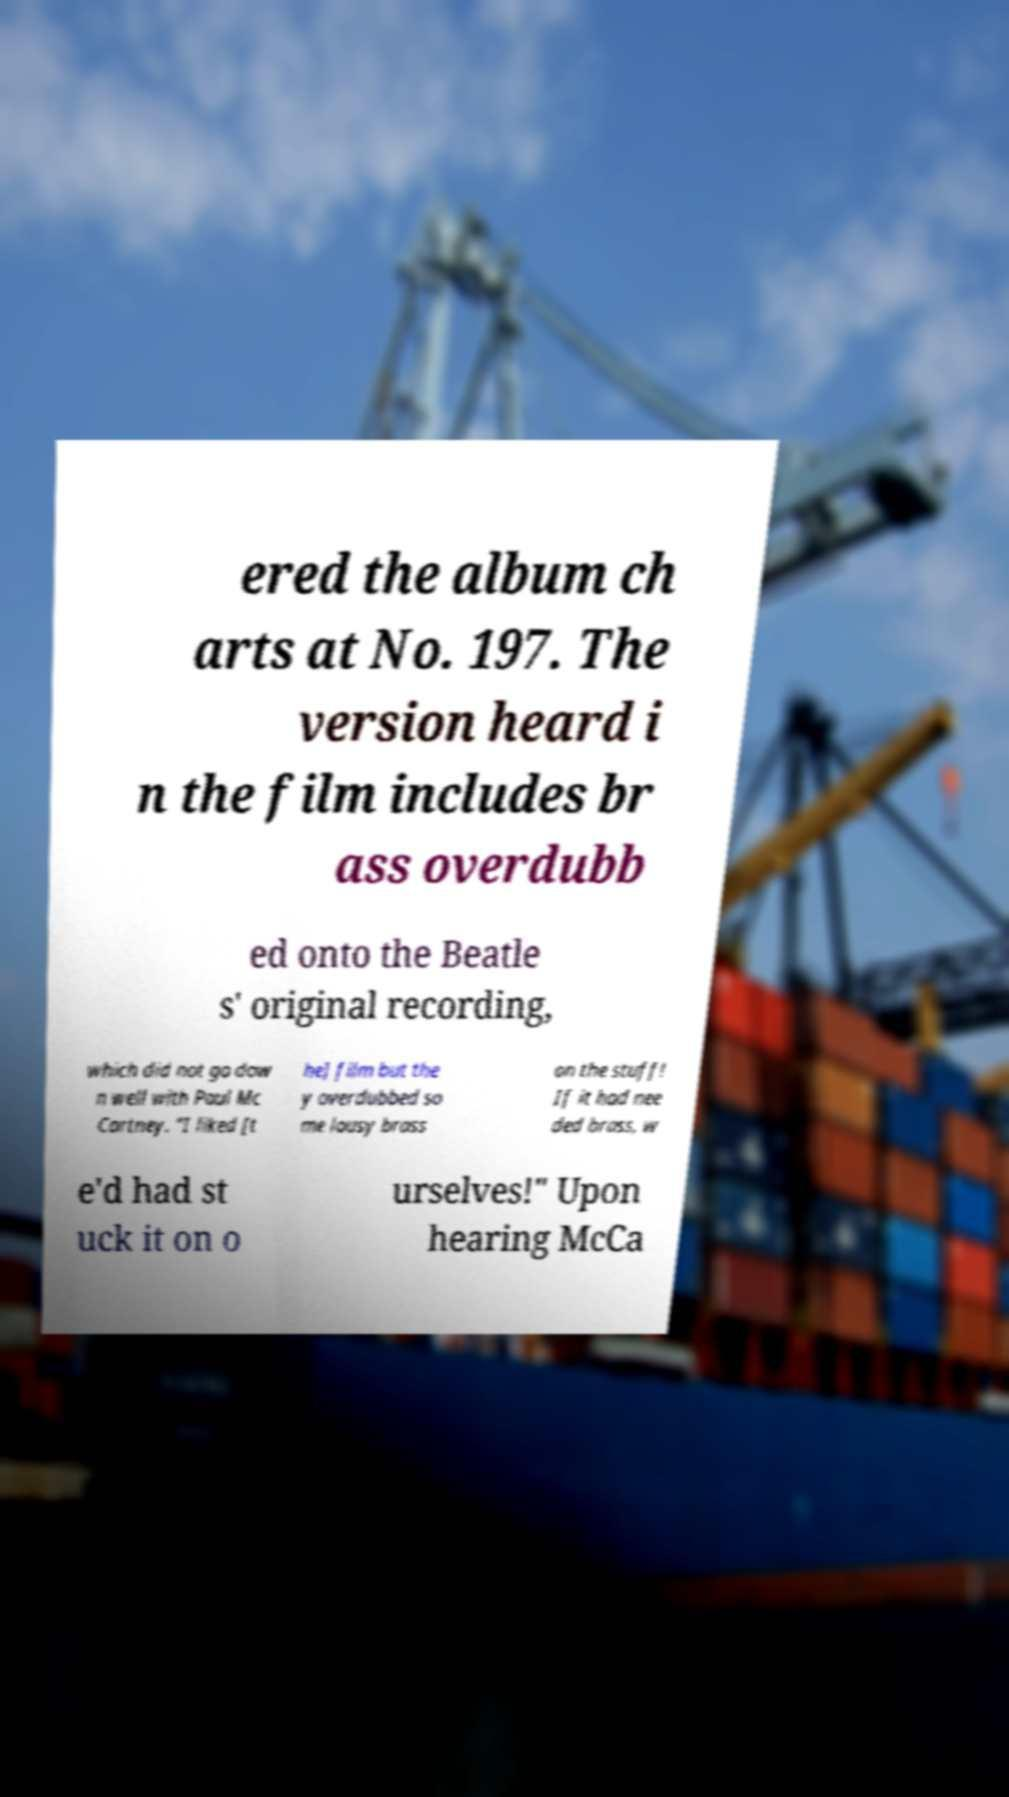For documentation purposes, I need the text within this image transcribed. Could you provide that? ered the album ch arts at No. 197. The version heard i n the film includes br ass overdubb ed onto the Beatle s' original recording, which did not go dow n well with Paul Mc Cartney. "I liked [t he] film but the y overdubbed so me lousy brass on the stuff! If it had nee ded brass, w e'd had st uck it on o urselves!" Upon hearing McCa 